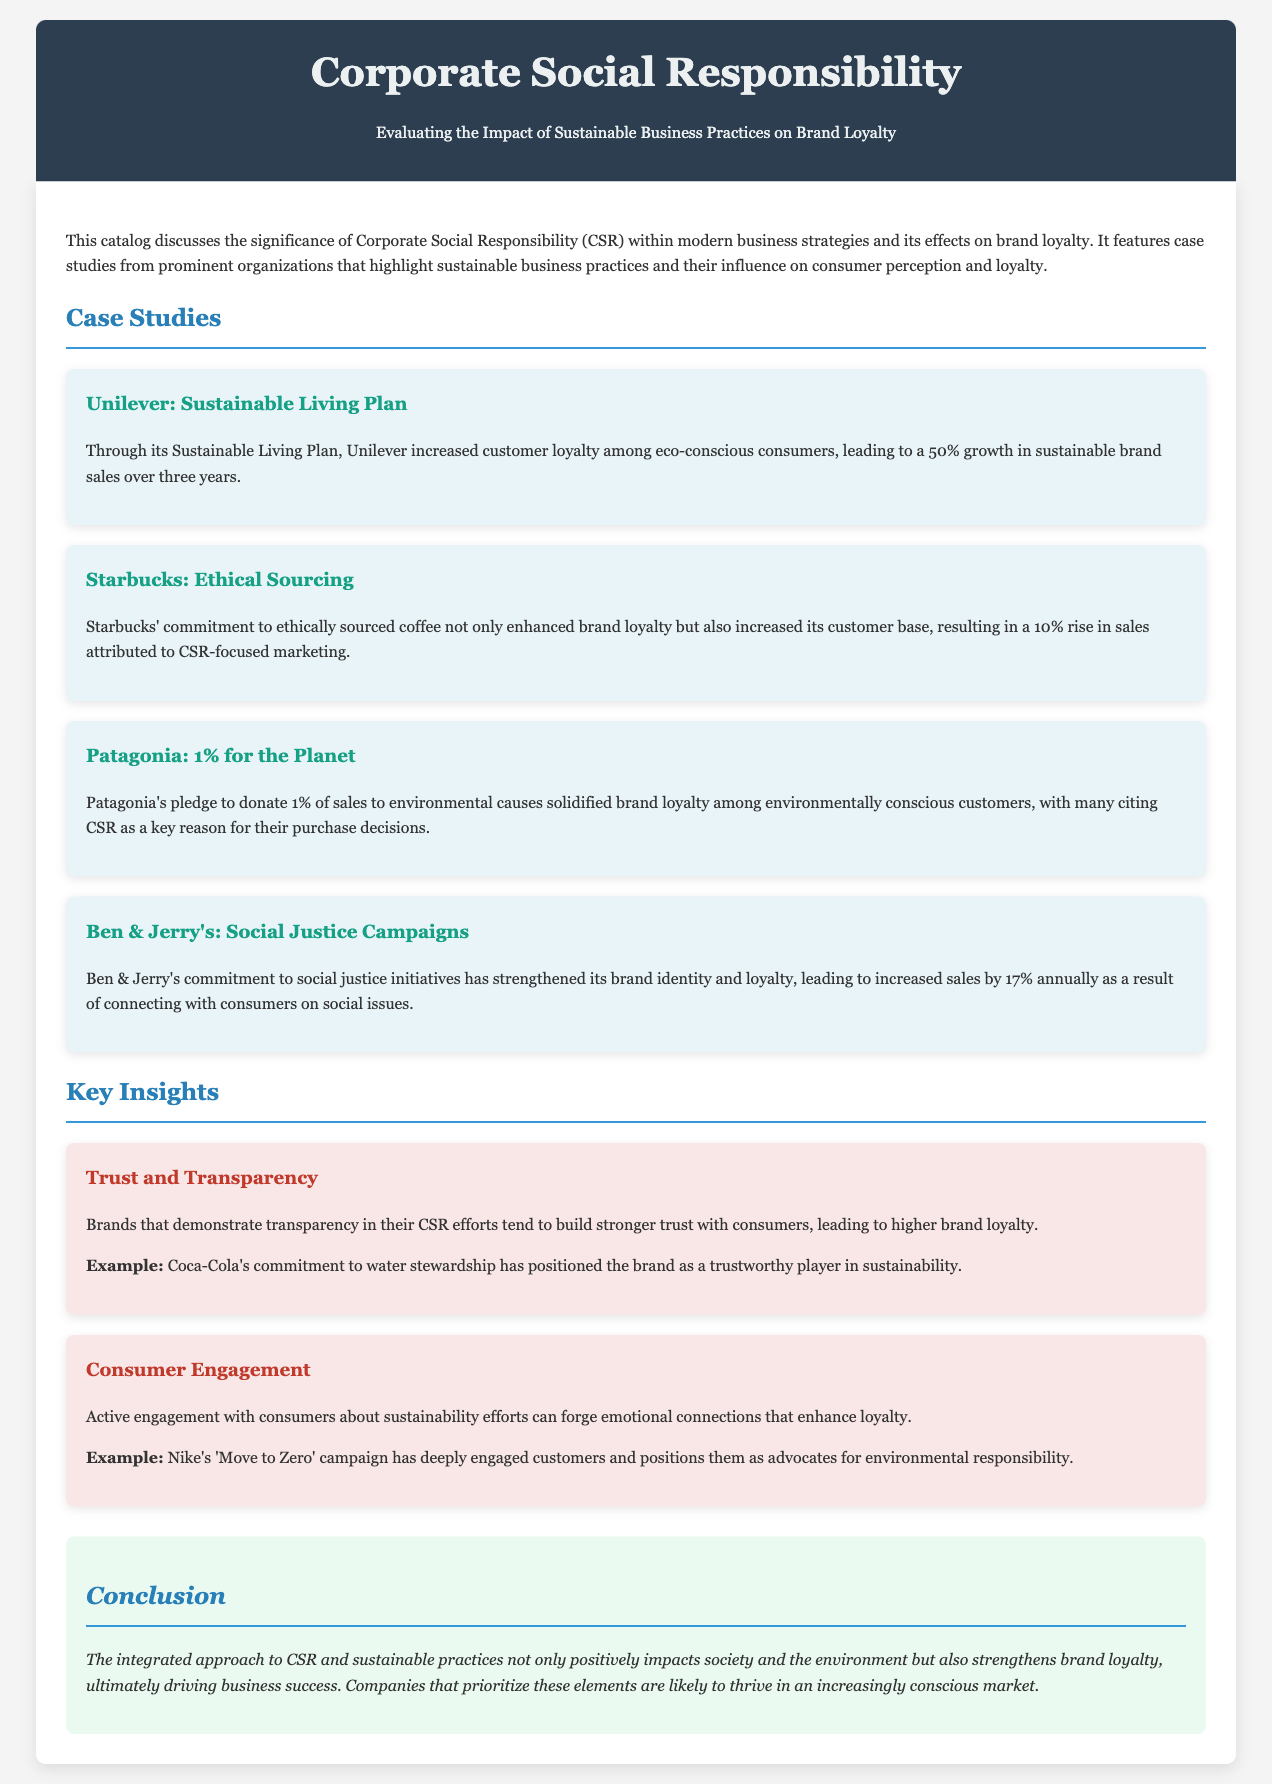What is the title of the catalog? The title of the catalog is stated at the top of the document, indicating its main focus.
Answer: Corporate Social Responsibility: Evaluating the Impact of Sustainable Business Practices on Brand Loyalty Which company's Sustainable Living Plan led to a growth in sales? The document mentions Unilever and its Sustainable Living Plan as a driver of sales growth.
Answer: Unilever What percentage of sales does Patagonia donate to environmental causes? The case study about Patagonia specifies the percentage they donate to highlight their commitment to sustainability.
Answer: 1% How much did Starbucks' sales rise due to CSR-focused marketing? The document states the impact of Starbucks' CSR marketing on its sales figures.
Answer: 10% Which campaign is associated with Nike's engagement with consumers? The document cites a specific campaign that has fostered consumer engagement and loyalty.
Answer: Move to Zero What annual sales increase has Ben & Jerry's experienced related to social justice initiatives? The document provides a percentage reflecting Ben & Jerry's sales growth related to its commitment to social issues.
Answer: 17% What is a key factor for building stronger trust with consumers according to the insights? The document outlines an important aspect related to consumer trust in the context of CSR efforts.
Answer: Transparency What is one major benefit of integrating CSR with business practices? The conclusion summarizes a primary outcome of combining CSR and sustainable practices within businesses.
Answer: Brand loyalty 